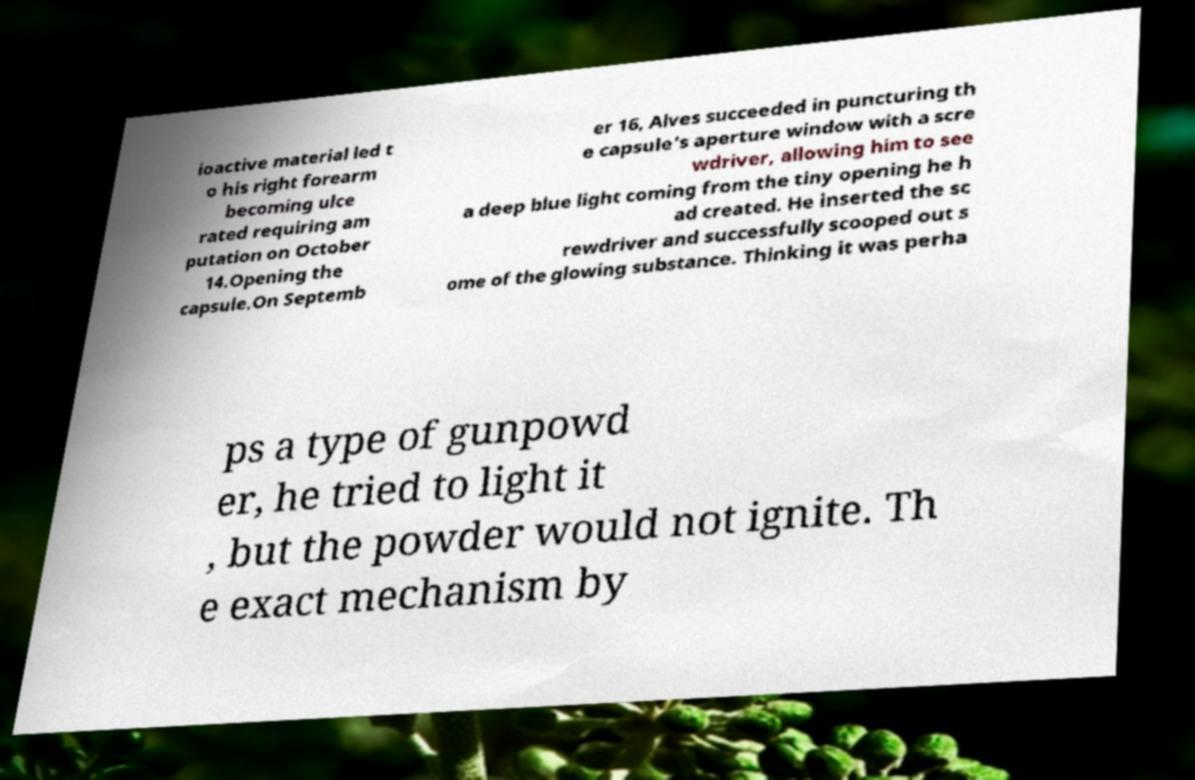Can you read and provide the text displayed in the image?This photo seems to have some interesting text. Can you extract and type it out for me? ioactive material led t o his right forearm becoming ulce rated requiring am putation on October 14.Opening the capsule.On Septemb er 16, Alves succeeded in puncturing th e capsule's aperture window with a scre wdriver, allowing him to see a deep blue light coming from the tiny opening he h ad created. He inserted the sc rewdriver and successfully scooped out s ome of the glowing substance. Thinking it was perha ps a type of gunpowd er, he tried to light it , but the powder would not ignite. Th e exact mechanism by 